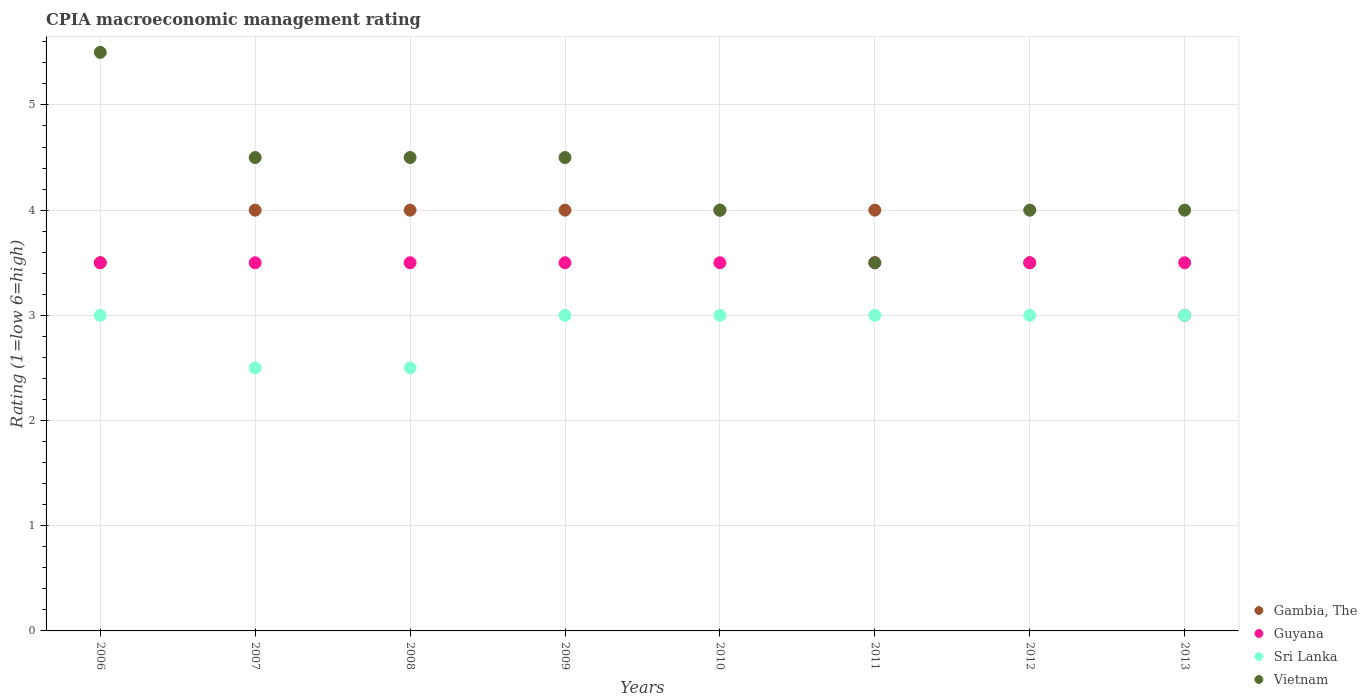How many different coloured dotlines are there?
Your answer should be very brief. 4. Is the number of dotlines equal to the number of legend labels?
Your answer should be compact. Yes. Across all years, what is the maximum CPIA rating in Gambia, The?
Your response must be concise. 4. In which year was the CPIA rating in Sri Lanka maximum?
Offer a terse response. 2006. In which year was the CPIA rating in Sri Lanka minimum?
Offer a terse response. 2007. What is the total CPIA rating in Guyana in the graph?
Ensure brevity in your answer.  28. What is the difference between the CPIA rating in Sri Lanka in 2010 and the CPIA rating in Vietnam in 2007?
Give a very brief answer. -1.5. Is the CPIA rating in Vietnam in 2012 less than that in 2013?
Provide a short and direct response. No. What is the difference between the highest and the lowest CPIA rating in Guyana?
Provide a succinct answer. 0. In how many years, is the CPIA rating in Gambia, The greater than the average CPIA rating in Gambia, The taken over all years?
Your answer should be compact. 5. Is it the case that in every year, the sum of the CPIA rating in Guyana and CPIA rating in Gambia, The  is greater than the sum of CPIA rating in Vietnam and CPIA rating in Sri Lanka?
Offer a terse response. Yes. Is the CPIA rating in Vietnam strictly less than the CPIA rating in Sri Lanka over the years?
Offer a very short reply. No. How many dotlines are there?
Your answer should be compact. 4. Does the graph contain any zero values?
Keep it short and to the point. No. How are the legend labels stacked?
Keep it short and to the point. Vertical. What is the title of the graph?
Offer a terse response. CPIA macroeconomic management rating. Does "Thailand" appear as one of the legend labels in the graph?
Provide a succinct answer. No. What is the label or title of the X-axis?
Your answer should be compact. Years. What is the label or title of the Y-axis?
Provide a succinct answer. Rating (1=low 6=high). What is the Rating (1=low 6=high) in Gambia, The in 2006?
Offer a very short reply. 3.5. What is the Rating (1=low 6=high) in Guyana in 2006?
Your response must be concise. 3.5. What is the Rating (1=low 6=high) in Vietnam in 2006?
Offer a very short reply. 5.5. What is the Rating (1=low 6=high) in Gambia, The in 2007?
Give a very brief answer. 4. What is the Rating (1=low 6=high) in Guyana in 2007?
Ensure brevity in your answer.  3.5. What is the Rating (1=low 6=high) in Gambia, The in 2008?
Offer a very short reply. 4. What is the Rating (1=low 6=high) of Guyana in 2008?
Provide a short and direct response. 3.5. What is the Rating (1=low 6=high) in Sri Lanka in 2008?
Make the answer very short. 2.5. What is the Rating (1=low 6=high) of Gambia, The in 2009?
Offer a terse response. 4. What is the Rating (1=low 6=high) in Sri Lanka in 2009?
Ensure brevity in your answer.  3. What is the Rating (1=low 6=high) of Vietnam in 2010?
Provide a succinct answer. 4. What is the Rating (1=low 6=high) of Gambia, The in 2011?
Provide a short and direct response. 4. What is the Rating (1=low 6=high) in Guyana in 2011?
Your answer should be compact. 3.5. What is the Rating (1=low 6=high) of Sri Lanka in 2011?
Provide a short and direct response. 3. What is the Rating (1=low 6=high) of Vietnam in 2012?
Make the answer very short. 4. What is the Rating (1=low 6=high) in Gambia, The in 2013?
Ensure brevity in your answer.  3. What is the Rating (1=low 6=high) of Guyana in 2013?
Offer a terse response. 3.5. Across all years, what is the maximum Rating (1=low 6=high) in Gambia, The?
Offer a terse response. 4. Across all years, what is the maximum Rating (1=low 6=high) in Guyana?
Provide a short and direct response. 3.5. Across all years, what is the minimum Rating (1=low 6=high) in Gambia, The?
Offer a terse response. 3. Across all years, what is the minimum Rating (1=low 6=high) in Guyana?
Provide a succinct answer. 3.5. What is the total Rating (1=low 6=high) of Gambia, The in the graph?
Your response must be concise. 30. What is the total Rating (1=low 6=high) in Guyana in the graph?
Give a very brief answer. 28. What is the total Rating (1=low 6=high) in Sri Lanka in the graph?
Offer a terse response. 23. What is the total Rating (1=low 6=high) of Vietnam in the graph?
Provide a succinct answer. 34.5. What is the difference between the Rating (1=low 6=high) in Gambia, The in 2006 and that in 2007?
Your response must be concise. -0.5. What is the difference between the Rating (1=low 6=high) of Guyana in 2006 and that in 2007?
Your answer should be very brief. 0. What is the difference between the Rating (1=low 6=high) in Vietnam in 2006 and that in 2007?
Give a very brief answer. 1. What is the difference between the Rating (1=low 6=high) of Gambia, The in 2006 and that in 2008?
Keep it short and to the point. -0.5. What is the difference between the Rating (1=low 6=high) of Guyana in 2006 and that in 2008?
Provide a short and direct response. 0. What is the difference between the Rating (1=low 6=high) of Gambia, The in 2006 and that in 2009?
Offer a very short reply. -0.5. What is the difference between the Rating (1=low 6=high) of Gambia, The in 2006 and that in 2010?
Your answer should be very brief. -0.5. What is the difference between the Rating (1=low 6=high) in Gambia, The in 2006 and that in 2011?
Keep it short and to the point. -0.5. What is the difference between the Rating (1=low 6=high) of Guyana in 2006 and that in 2011?
Give a very brief answer. 0. What is the difference between the Rating (1=low 6=high) in Sri Lanka in 2006 and that in 2011?
Give a very brief answer. 0. What is the difference between the Rating (1=low 6=high) in Gambia, The in 2006 and that in 2012?
Offer a very short reply. 0. What is the difference between the Rating (1=low 6=high) of Guyana in 2006 and that in 2013?
Offer a very short reply. 0. What is the difference between the Rating (1=low 6=high) in Sri Lanka in 2006 and that in 2013?
Offer a terse response. 0. What is the difference between the Rating (1=low 6=high) in Vietnam in 2006 and that in 2013?
Keep it short and to the point. 1.5. What is the difference between the Rating (1=low 6=high) of Vietnam in 2007 and that in 2008?
Offer a terse response. 0. What is the difference between the Rating (1=low 6=high) of Vietnam in 2007 and that in 2009?
Offer a terse response. 0. What is the difference between the Rating (1=low 6=high) of Sri Lanka in 2007 and that in 2010?
Make the answer very short. -0.5. What is the difference between the Rating (1=low 6=high) in Sri Lanka in 2007 and that in 2011?
Make the answer very short. -0.5. What is the difference between the Rating (1=low 6=high) of Guyana in 2007 and that in 2013?
Provide a succinct answer. 0. What is the difference between the Rating (1=low 6=high) of Sri Lanka in 2007 and that in 2013?
Your answer should be very brief. -0.5. What is the difference between the Rating (1=low 6=high) of Gambia, The in 2008 and that in 2009?
Provide a succinct answer. 0. What is the difference between the Rating (1=low 6=high) of Gambia, The in 2008 and that in 2010?
Your answer should be compact. 0. What is the difference between the Rating (1=low 6=high) of Vietnam in 2008 and that in 2010?
Provide a succinct answer. 0.5. What is the difference between the Rating (1=low 6=high) in Vietnam in 2008 and that in 2011?
Provide a succinct answer. 1. What is the difference between the Rating (1=low 6=high) of Guyana in 2008 and that in 2012?
Ensure brevity in your answer.  0. What is the difference between the Rating (1=low 6=high) of Gambia, The in 2008 and that in 2013?
Give a very brief answer. 1. What is the difference between the Rating (1=low 6=high) in Sri Lanka in 2009 and that in 2010?
Make the answer very short. 0. What is the difference between the Rating (1=low 6=high) in Guyana in 2009 and that in 2011?
Offer a very short reply. 0. What is the difference between the Rating (1=low 6=high) in Sri Lanka in 2009 and that in 2013?
Offer a terse response. 0. What is the difference between the Rating (1=low 6=high) of Vietnam in 2009 and that in 2013?
Provide a succinct answer. 0.5. What is the difference between the Rating (1=low 6=high) of Vietnam in 2010 and that in 2011?
Your response must be concise. 0.5. What is the difference between the Rating (1=low 6=high) in Guyana in 2010 and that in 2012?
Ensure brevity in your answer.  0. What is the difference between the Rating (1=low 6=high) of Vietnam in 2010 and that in 2012?
Ensure brevity in your answer.  0. What is the difference between the Rating (1=low 6=high) in Guyana in 2010 and that in 2013?
Offer a very short reply. 0. What is the difference between the Rating (1=low 6=high) in Sri Lanka in 2010 and that in 2013?
Your response must be concise. 0. What is the difference between the Rating (1=low 6=high) of Vietnam in 2010 and that in 2013?
Provide a succinct answer. 0. What is the difference between the Rating (1=low 6=high) of Gambia, The in 2011 and that in 2013?
Your answer should be compact. 1. What is the difference between the Rating (1=low 6=high) of Sri Lanka in 2011 and that in 2013?
Your answer should be very brief. 0. What is the difference between the Rating (1=low 6=high) in Vietnam in 2011 and that in 2013?
Provide a short and direct response. -0.5. What is the difference between the Rating (1=low 6=high) of Guyana in 2012 and that in 2013?
Provide a succinct answer. 0. What is the difference between the Rating (1=low 6=high) in Sri Lanka in 2012 and that in 2013?
Ensure brevity in your answer.  0. What is the difference between the Rating (1=low 6=high) in Gambia, The in 2006 and the Rating (1=low 6=high) in Sri Lanka in 2007?
Ensure brevity in your answer.  1. What is the difference between the Rating (1=low 6=high) of Gambia, The in 2006 and the Rating (1=low 6=high) of Sri Lanka in 2008?
Your answer should be compact. 1. What is the difference between the Rating (1=low 6=high) of Gambia, The in 2006 and the Rating (1=low 6=high) of Vietnam in 2008?
Your answer should be very brief. -1. What is the difference between the Rating (1=low 6=high) in Guyana in 2006 and the Rating (1=low 6=high) in Sri Lanka in 2008?
Your response must be concise. 1. What is the difference between the Rating (1=low 6=high) in Guyana in 2006 and the Rating (1=low 6=high) in Vietnam in 2008?
Offer a very short reply. -1. What is the difference between the Rating (1=low 6=high) of Gambia, The in 2006 and the Rating (1=low 6=high) of Guyana in 2009?
Provide a short and direct response. 0. What is the difference between the Rating (1=low 6=high) in Gambia, The in 2006 and the Rating (1=low 6=high) in Vietnam in 2009?
Offer a terse response. -1. What is the difference between the Rating (1=low 6=high) of Guyana in 2006 and the Rating (1=low 6=high) of Vietnam in 2009?
Make the answer very short. -1. What is the difference between the Rating (1=low 6=high) of Gambia, The in 2006 and the Rating (1=low 6=high) of Vietnam in 2010?
Give a very brief answer. -0.5. What is the difference between the Rating (1=low 6=high) in Sri Lanka in 2006 and the Rating (1=low 6=high) in Vietnam in 2010?
Provide a short and direct response. -1. What is the difference between the Rating (1=low 6=high) of Gambia, The in 2006 and the Rating (1=low 6=high) of Vietnam in 2011?
Offer a very short reply. 0. What is the difference between the Rating (1=low 6=high) in Sri Lanka in 2006 and the Rating (1=low 6=high) in Vietnam in 2011?
Ensure brevity in your answer.  -0.5. What is the difference between the Rating (1=low 6=high) of Gambia, The in 2006 and the Rating (1=low 6=high) of Sri Lanka in 2012?
Ensure brevity in your answer.  0.5. What is the difference between the Rating (1=low 6=high) of Gambia, The in 2006 and the Rating (1=low 6=high) of Vietnam in 2012?
Give a very brief answer. -0.5. What is the difference between the Rating (1=low 6=high) of Gambia, The in 2006 and the Rating (1=low 6=high) of Vietnam in 2013?
Provide a succinct answer. -0.5. What is the difference between the Rating (1=low 6=high) of Guyana in 2006 and the Rating (1=low 6=high) of Vietnam in 2013?
Offer a terse response. -0.5. What is the difference between the Rating (1=low 6=high) in Gambia, The in 2007 and the Rating (1=low 6=high) in Guyana in 2008?
Make the answer very short. 0.5. What is the difference between the Rating (1=low 6=high) in Gambia, The in 2007 and the Rating (1=low 6=high) in Sri Lanka in 2008?
Your answer should be compact. 1.5. What is the difference between the Rating (1=low 6=high) of Gambia, The in 2007 and the Rating (1=low 6=high) of Vietnam in 2008?
Your answer should be compact. -0.5. What is the difference between the Rating (1=low 6=high) in Guyana in 2007 and the Rating (1=low 6=high) in Vietnam in 2008?
Provide a succinct answer. -1. What is the difference between the Rating (1=low 6=high) of Gambia, The in 2007 and the Rating (1=low 6=high) of Sri Lanka in 2009?
Provide a short and direct response. 1. What is the difference between the Rating (1=low 6=high) in Gambia, The in 2007 and the Rating (1=low 6=high) in Guyana in 2010?
Offer a terse response. 0.5. What is the difference between the Rating (1=low 6=high) of Gambia, The in 2007 and the Rating (1=low 6=high) of Sri Lanka in 2010?
Your response must be concise. 1. What is the difference between the Rating (1=low 6=high) of Gambia, The in 2007 and the Rating (1=low 6=high) of Vietnam in 2010?
Your answer should be very brief. 0. What is the difference between the Rating (1=low 6=high) of Guyana in 2007 and the Rating (1=low 6=high) of Vietnam in 2010?
Offer a very short reply. -0.5. What is the difference between the Rating (1=low 6=high) in Sri Lanka in 2007 and the Rating (1=low 6=high) in Vietnam in 2010?
Your answer should be very brief. -1.5. What is the difference between the Rating (1=low 6=high) in Gambia, The in 2007 and the Rating (1=low 6=high) in Guyana in 2011?
Your answer should be compact. 0.5. What is the difference between the Rating (1=low 6=high) of Gambia, The in 2007 and the Rating (1=low 6=high) of Vietnam in 2011?
Ensure brevity in your answer.  0.5. What is the difference between the Rating (1=low 6=high) in Guyana in 2007 and the Rating (1=low 6=high) in Vietnam in 2011?
Offer a very short reply. 0. What is the difference between the Rating (1=low 6=high) in Sri Lanka in 2007 and the Rating (1=low 6=high) in Vietnam in 2011?
Offer a very short reply. -1. What is the difference between the Rating (1=low 6=high) of Guyana in 2007 and the Rating (1=low 6=high) of Sri Lanka in 2012?
Give a very brief answer. 0.5. What is the difference between the Rating (1=low 6=high) in Guyana in 2007 and the Rating (1=low 6=high) in Vietnam in 2012?
Give a very brief answer. -0.5. What is the difference between the Rating (1=low 6=high) of Guyana in 2007 and the Rating (1=low 6=high) of Vietnam in 2013?
Your response must be concise. -0.5. What is the difference between the Rating (1=low 6=high) in Gambia, The in 2008 and the Rating (1=low 6=high) in Guyana in 2009?
Provide a succinct answer. 0.5. What is the difference between the Rating (1=low 6=high) in Guyana in 2008 and the Rating (1=low 6=high) in Vietnam in 2009?
Offer a very short reply. -1. What is the difference between the Rating (1=low 6=high) of Gambia, The in 2008 and the Rating (1=low 6=high) of Vietnam in 2010?
Your answer should be very brief. 0. What is the difference between the Rating (1=low 6=high) in Guyana in 2008 and the Rating (1=low 6=high) in Sri Lanka in 2010?
Keep it short and to the point. 0.5. What is the difference between the Rating (1=low 6=high) in Gambia, The in 2008 and the Rating (1=low 6=high) in Guyana in 2011?
Your answer should be compact. 0.5. What is the difference between the Rating (1=low 6=high) of Gambia, The in 2008 and the Rating (1=low 6=high) of Sri Lanka in 2011?
Your answer should be compact. 1. What is the difference between the Rating (1=low 6=high) of Sri Lanka in 2008 and the Rating (1=low 6=high) of Vietnam in 2011?
Keep it short and to the point. -1. What is the difference between the Rating (1=low 6=high) of Gambia, The in 2008 and the Rating (1=low 6=high) of Vietnam in 2012?
Offer a very short reply. 0. What is the difference between the Rating (1=low 6=high) in Sri Lanka in 2008 and the Rating (1=low 6=high) in Vietnam in 2012?
Your answer should be compact. -1.5. What is the difference between the Rating (1=low 6=high) of Gambia, The in 2008 and the Rating (1=low 6=high) of Guyana in 2013?
Keep it short and to the point. 0.5. What is the difference between the Rating (1=low 6=high) of Guyana in 2008 and the Rating (1=low 6=high) of Sri Lanka in 2013?
Your answer should be very brief. 0.5. What is the difference between the Rating (1=low 6=high) of Guyana in 2008 and the Rating (1=low 6=high) of Vietnam in 2013?
Your answer should be compact. -0.5. What is the difference between the Rating (1=low 6=high) of Sri Lanka in 2008 and the Rating (1=low 6=high) of Vietnam in 2013?
Provide a succinct answer. -1.5. What is the difference between the Rating (1=low 6=high) of Guyana in 2009 and the Rating (1=low 6=high) of Vietnam in 2010?
Offer a terse response. -0.5. What is the difference between the Rating (1=low 6=high) in Gambia, The in 2009 and the Rating (1=low 6=high) in Sri Lanka in 2011?
Your answer should be very brief. 1. What is the difference between the Rating (1=low 6=high) in Gambia, The in 2009 and the Rating (1=low 6=high) in Guyana in 2012?
Keep it short and to the point. 0.5. What is the difference between the Rating (1=low 6=high) of Gambia, The in 2009 and the Rating (1=low 6=high) of Sri Lanka in 2012?
Give a very brief answer. 1. What is the difference between the Rating (1=low 6=high) in Gambia, The in 2009 and the Rating (1=low 6=high) in Vietnam in 2012?
Offer a terse response. 0. What is the difference between the Rating (1=low 6=high) in Guyana in 2009 and the Rating (1=low 6=high) in Sri Lanka in 2012?
Give a very brief answer. 0.5. What is the difference between the Rating (1=low 6=high) in Gambia, The in 2009 and the Rating (1=low 6=high) in Guyana in 2013?
Offer a very short reply. 0.5. What is the difference between the Rating (1=low 6=high) of Gambia, The in 2009 and the Rating (1=low 6=high) of Sri Lanka in 2013?
Offer a very short reply. 1. What is the difference between the Rating (1=low 6=high) in Sri Lanka in 2009 and the Rating (1=low 6=high) in Vietnam in 2013?
Your answer should be very brief. -1. What is the difference between the Rating (1=low 6=high) in Guyana in 2010 and the Rating (1=low 6=high) in Sri Lanka in 2011?
Offer a terse response. 0.5. What is the difference between the Rating (1=low 6=high) of Gambia, The in 2010 and the Rating (1=low 6=high) of Guyana in 2012?
Provide a short and direct response. 0.5. What is the difference between the Rating (1=low 6=high) in Gambia, The in 2010 and the Rating (1=low 6=high) in Sri Lanka in 2012?
Provide a succinct answer. 1. What is the difference between the Rating (1=low 6=high) in Gambia, The in 2010 and the Rating (1=low 6=high) in Vietnam in 2012?
Make the answer very short. 0. What is the difference between the Rating (1=low 6=high) of Guyana in 2010 and the Rating (1=low 6=high) of Sri Lanka in 2012?
Provide a succinct answer. 0.5. What is the difference between the Rating (1=low 6=high) of Guyana in 2010 and the Rating (1=low 6=high) of Vietnam in 2012?
Your answer should be compact. -0.5. What is the difference between the Rating (1=low 6=high) of Sri Lanka in 2010 and the Rating (1=low 6=high) of Vietnam in 2012?
Keep it short and to the point. -1. What is the difference between the Rating (1=low 6=high) in Gambia, The in 2010 and the Rating (1=low 6=high) in Sri Lanka in 2013?
Provide a short and direct response. 1. What is the difference between the Rating (1=low 6=high) in Guyana in 2010 and the Rating (1=low 6=high) in Sri Lanka in 2013?
Provide a short and direct response. 0.5. What is the difference between the Rating (1=low 6=high) in Gambia, The in 2011 and the Rating (1=low 6=high) in Guyana in 2012?
Your answer should be compact. 0.5. What is the difference between the Rating (1=low 6=high) of Gambia, The in 2011 and the Rating (1=low 6=high) of Vietnam in 2012?
Your answer should be compact. 0. What is the difference between the Rating (1=low 6=high) of Guyana in 2011 and the Rating (1=low 6=high) of Sri Lanka in 2012?
Your answer should be very brief. 0.5. What is the difference between the Rating (1=low 6=high) of Guyana in 2011 and the Rating (1=low 6=high) of Vietnam in 2012?
Make the answer very short. -0.5. What is the difference between the Rating (1=low 6=high) of Sri Lanka in 2011 and the Rating (1=low 6=high) of Vietnam in 2012?
Your answer should be compact. -1. What is the difference between the Rating (1=low 6=high) of Guyana in 2011 and the Rating (1=low 6=high) of Vietnam in 2013?
Keep it short and to the point. -0.5. What is the average Rating (1=low 6=high) in Gambia, The per year?
Provide a succinct answer. 3.75. What is the average Rating (1=low 6=high) in Sri Lanka per year?
Make the answer very short. 2.88. What is the average Rating (1=low 6=high) of Vietnam per year?
Your answer should be compact. 4.31. In the year 2006, what is the difference between the Rating (1=low 6=high) of Gambia, The and Rating (1=low 6=high) of Vietnam?
Your answer should be very brief. -2. In the year 2007, what is the difference between the Rating (1=low 6=high) in Gambia, The and Rating (1=low 6=high) in Sri Lanka?
Offer a terse response. 1.5. In the year 2007, what is the difference between the Rating (1=low 6=high) in Sri Lanka and Rating (1=low 6=high) in Vietnam?
Ensure brevity in your answer.  -2. In the year 2008, what is the difference between the Rating (1=low 6=high) of Gambia, The and Rating (1=low 6=high) of Guyana?
Provide a succinct answer. 0.5. In the year 2008, what is the difference between the Rating (1=low 6=high) in Gambia, The and Rating (1=low 6=high) in Sri Lanka?
Your answer should be very brief. 1.5. In the year 2008, what is the difference between the Rating (1=low 6=high) of Gambia, The and Rating (1=low 6=high) of Vietnam?
Make the answer very short. -0.5. In the year 2008, what is the difference between the Rating (1=low 6=high) of Guyana and Rating (1=low 6=high) of Sri Lanka?
Give a very brief answer. 1. In the year 2008, what is the difference between the Rating (1=low 6=high) of Sri Lanka and Rating (1=low 6=high) of Vietnam?
Your response must be concise. -2. In the year 2009, what is the difference between the Rating (1=low 6=high) in Gambia, The and Rating (1=low 6=high) in Guyana?
Your response must be concise. 0.5. In the year 2009, what is the difference between the Rating (1=low 6=high) of Gambia, The and Rating (1=low 6=high) of Sri Lanka?
Your answer should be very brief. 1. In the year 2009, what is the difference between the Rating (1=low 6=high) in Gambia, The and Rating (1=low 6=high) in Vietnam?
Offer a very short reply. -0.5. In the year 2009, what is the difference between the Rating (1=low 6=high) in Guyana and Rating (1=low 6=high) in Vietnam?
Provide a succinct answer. -1. In the year 2010, what is the difference between the Rating (1=low 6=high) in Gambia, The and Rating (1=low 6=high) in Sri Lanka?
Offer a very short reply. 1. In the year 2010, what is the difference between the Rating (1=low 6=high) of Guyana and Rating (1=low 6=high) of Sri Lanka?
Make the answer very short. 0.5. In the year 2010, what is the difference between the Rating (1=low 6=high) in Sri Lanka and Rating (1=low 6=high) in Vietnam?
Give a very brief answer. -1. In the year 2011, what is the difference between the Rating (1=low 6=high) of Gambia, The and Rating (1=low 6=high) of Guyana?
Make the answer very short. 0.5. In the year 2011, what is the difference between the Rating (1=low 6=high) in Gambia, The and Rating (1=low 6=high) in Vietnam?
Offer a terse response. 0.5. In the year 2011, what is the difference between the Rating (1=low 6=high) of Guyana and Rating (1=low 6=high) of Sri Lanka?
Provide a succinct answer. 0.5. In the year 2011, what is the difference between the Rating (1=low 6=high) in Guyana and Rating (1=low 6=high) in Vietnam?
Your answer should be very brief. 0. In the year 2011, what is the difference between the Rating (1=low 6=high) in Sri Lanka and Rating (1=low 6=high) in Vietnam?
Your answer should be very brief. -0.5. In the year 2012, what is the difference between the Rating (1=low 6=high) of Guyana and Rating (1=low 6=high) of Sri Lanka?
Ensure brevity in your answer.  0.5. In the year 2013, what is the difference between the Rating (1=low 6=high) in Gambia, The and Rating (1=low 6=high) in Guyana?
Give a very brief answer. -0.5. In the year 2013, what is the difference between the Rating (1=low 6=high) in Gambia, The and Rating (1=low 6=high) in Sri Lanka?
Offer a terse response. 0. In the year 2013, what is the difference between the Rating (1=low 6=high) of Gambia, The and Rating (1=low 6=high) of Vietnam?
Your answer should be very brief. -1. In the year 2013, what is the difference between the Rating (1=low 6=high) of Sri Lanka and Rating (1=low 6=high) of Vietnam?
Ensure brevity in your answer.  -1. What is the ratio of the Rating (1=low 6=high) of Gambia, The in 2006 to that in 2007?
Provide a short and direct response. 0.88. What is the ratio of the Rating (1=low 6=high) of Vietnam in 2006 to that in 2007?
Keep it short and to the point. 1.22. What is the ratio of the Rating (1=low 6=high) in Guyana in 2006 to that in 2008?
Provide a succinct answer. 1. What is the ratio of the Rating (1=low 6=high) in Sri Lanka in 2006 to that in 2008?
Offer a very short reply. 1.2. What is the ratio of the Rating (1=low 6=high) in Vietnam in 2006 to that in 2008?
Offer a terse response. 1.22. What is the ratio of the Rating (1=low 6=high) of Gambia, The in 2006 to that in 2009?
Give a very brief answer. 0.88. What is the ratio of the Rating (1=low 6=high) of Guyana in 2006 to that in 2009?
Provide a short and direct response. 1. What is the ratio of the Rating (1=low 6=high) in Vietnam in 2006 to that in 2009?
Keep it short and to the point. 1.22. What is the ratio of the Rating (1=low 6=high) of Guyana in 2006 to that in 2010?
Give a very brief answer. 1. What is the ratio of the Rating (1=low 6=high) of Vietnam in 2006 to that in 2010?
Your response must be concise. 1.38. What is the ratio of the Rating (1=low 6=high) of Gambia, The in 2006 to that in 2011?
Provide a short and direct response. 0.88. What is the ratio of the Rating (1=low 6=high) of Guyana in 2006 to that in 2011?
Give a very brief answer. 1. What is the ratio of the Rating (1=low 6=high) of Vietnam in 2006 to that in 2011?
Offer a terse response. 1.57. What is the ratio of the Rating (1=low 6=high) of Gambia, The in 2006 to that in 2012?
Your answer should be very brief. 1. What is the ratio of the Rating (1=low 6=high) of Guyana in 2006 to that in 2012?
Keep it short and to the point. 1. What is the ratio of the Rating (1=low 6=high) of Sri Lanka in 2006 to that in 2012?
Your response must be concise. 1. What is the ratio of the Rating (1=low 6=high) of Vietnam in 2006 to that in 2012?
Your answer should be compact. 1.38. What is the ratio of the Rating (1=low 6=high) in Gambia, The in 2006 to that in 2013?
Your answer should be compact. 1.17. What is the ratio of the Rating (1=low 6=high) of Guyana in 2006 to that in 2013?
Offer a terse response. 1. What is the ratio of the Rating (1=low 6=high) in Sri Lanka in 2006 to that in 2013?
Your response must be concise. 1. What is the ratio of the Rating (1=low 6=high) in Vietnam in 2006 to that in 2013?
Your answer should be very brief. 1.38. What is the ratio of the Rating (1=low 6=high) of Vietnam in 2007 to that in 2008?
Make the answer very short. 1. What is the ratio of the Rating (1=low 6=high) of Gambia, The in 2007 to that in 2009?
Keep it short and to the point. 1. What is the ratio of the Rating (1=low 6=high) of Sri Lanka in 2007 to that in 2009?
Ensure brevity in your answer.  0.83. What is the ratio of the Rating (1=low 6=high) of Guyana in 2007 to that in 2011?
Keep it short and to the point. 1. What is the ratio of the Rating (1=low 6=high) of Gambia, The in 2007 to that in 2012?
Provide a short and direct response. 1.14. What is the ratio of the Rating (1=low 6=high) in Guyana in 2007 to that in 2012?
Make the answer very short. 1. What is the ratio of the Rating (1=low 6=high) of Gambia, The in 2007 to that in 2013?
Ensure brevity in your answer.  1.33. What is the ratio of the Rating (1=low 6=high) of Sri Lanka in 2007 to that in 2013?
Offer a terse response. 0.83. What is the ratio of the Rating (1=low 6=high) of Vietnam in 2007 to that in 2013?
Give a very brief answer. 1.12. What is the ratio of the Rating (1=low 6=high) in Gambia, The in 2008 to that in 2009?
Provide a short and direct response. 1. What is the ratio of the Rating (1=low 6=high) in Gambia, The in 2008 to that in 2010?
Offer a very short reply. 1. What is the ratio of the Rating (1=low 6=high) of Guyana in 2008 to that in 2010?
Keep it short and to the point. 1. What is the ratio of the Rating (1=low 6=high) of Sri Lanka in 2008 to that in 2011?
Make the answer very short. 0.83. What is the ratio of the Rating (1=low 6=high) in Vietnam in 2008 to that in 2011?
Ensure brevity in your answer.  1.29. What is the ratio of the Rating (1=low 6=high) in Gambia, The in 2008 to that in 2012?
Provide a short and direct response. 1.14. What is the ratio of the Rating (1=low 6=high) in Sri Lanka in 2008 to that in 2012?
Offer a very short reply. 0.83. What is the ratio of the Rating (1=low 6=high) in Vietnam in 2008 to that in 2012?
Your answer should be compact. 1.12. What is the ratio of the Rating (1=low 6=high) in Sri Lanka in 2008 to that in 2013?
Your answer should be compact. 0.83. What is the ratio of the Rating (1=low 6=high) in Vietnam in 2008 to that in 2013?
Your answer should be very brief. 1.12. What is the ratio of the Rating (1=low 6=high) of Gambia, The in 2009 to that in 2010?
Give a very brief answer. 1. What is the ratio of the Rating (1=low 6=high) in Guyana in 2009 to that in 2010?
Provide a succinct answer. 1. What is the ratio of the Rating (1=low 6=high) of Sri Lanka in 2009 to that in 2010?
Offer a terse response. 1. What is the ratio of the Rating (1=low 6=high) in Vietnam in 2009 to that in 2010?
Offer a very short reply. 1.12. What is the ratio of the Rating (1=low 6=high) of Gambia, The in 2009 to that in 2011?
Your answer should be very brief. 1. What is the ratio of the Rating (1=low 6=high) in Vietnam in 2009 to that in 2011?
Ensure brevity in your answer.  1.29. What is the ratio of the Rating (1=low 6=high) in Gambia, The in 2009 to that in 2012?
Give a very brief answer. 1.14. What is the ratio of the Rating (1=low 6=high) of Guyana in 2009 to that in 2012?
Offer a very short reply. 1. What is the ratio of the Rating (1=low 6=high) in Sri Lanka in 2009 to that in 2012?
Offer a terse response. 1. What is the ratio of the Rating (1=low 6=high) of Vietnam in 2009 to that in 2012?
Your answer should be compact. 1.12. What is the ratio of the Rating (1=low 6=high) of Guyana in 2009 to that in 2013?
Provide a short and direct response. 1. What is the ratio of the Rating (1=low 6=high) of Gambia, The in 2010 to that in 2011?
Ensure brevity in your answer.  1. What is the ratio of the Rating (1=low 6=high) of Guyana in 2010 to that in 2011?
Ensure brevity in your answer.  1. What is the ratio of the Rating (1=low 6=high) in Sri Lanka in 2010 to that in 2011?
Provide a succinct answer. 1. What is the ratio of the Rating (1=low 6=high) of Gambia, The in 2010 to that in 2012?
Make the answer very short. 1.14. What is the ratio of the Rating (1=low 6=high) of Sri Lanka in 2010 to that in 2012?
Keep it short and to the point. 1. What is the ratio of the Rating (1=low 6=high) of Vietnam in 2010 to that in 2012?
Make the answer very short. 1. What is the ratio of the Rating (1=low 6=high) in Guyana in 2010 to that in 2013?
Your response must be concise. 1. What is the ratio of the Rating (1=low 6=high) of Vietnam in 2010 to that in 2013?
Your answer should be very brief. 1. What is the ratio of the Rating (1=low 6=high) in Gambia, The in 2011 to that in 2013?
Give a very brief answer. 1.33. What is the ratio of the Rating (1=low 6=high) in Gambia, The in 2012 to that in 2013?
Make the answer very short. 1.17. What is the ratio of the Rating (1=low 6=high) of Guyana in 2012 to that in 2013?
Provide a short and direct response. 1. What is the ratio of the Rating (1=low 6=high) in Sri Lanka in 2012 to that in 2013?
Ensure brevity in your answer.  1. What is the difference between the highest and the second highest Rating (1=low 6=high) of Gambia, The?
Your response must be concise. 0. What is the difference between the highest and the lowest Rating (1=low 6=high) in Vietnam?
Offer a terse response. 2. 